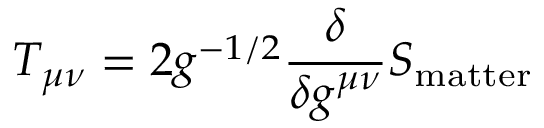Convert formula to latex. <formula><loc_0><loc_0><loc_500><loc_500>T _ { \mu \nu } = 2 g ^ { - 1 / 2 } \frac { \delta } { \delta g ^ { \mu \nu } } S _ { m a t t e r }</formula> 